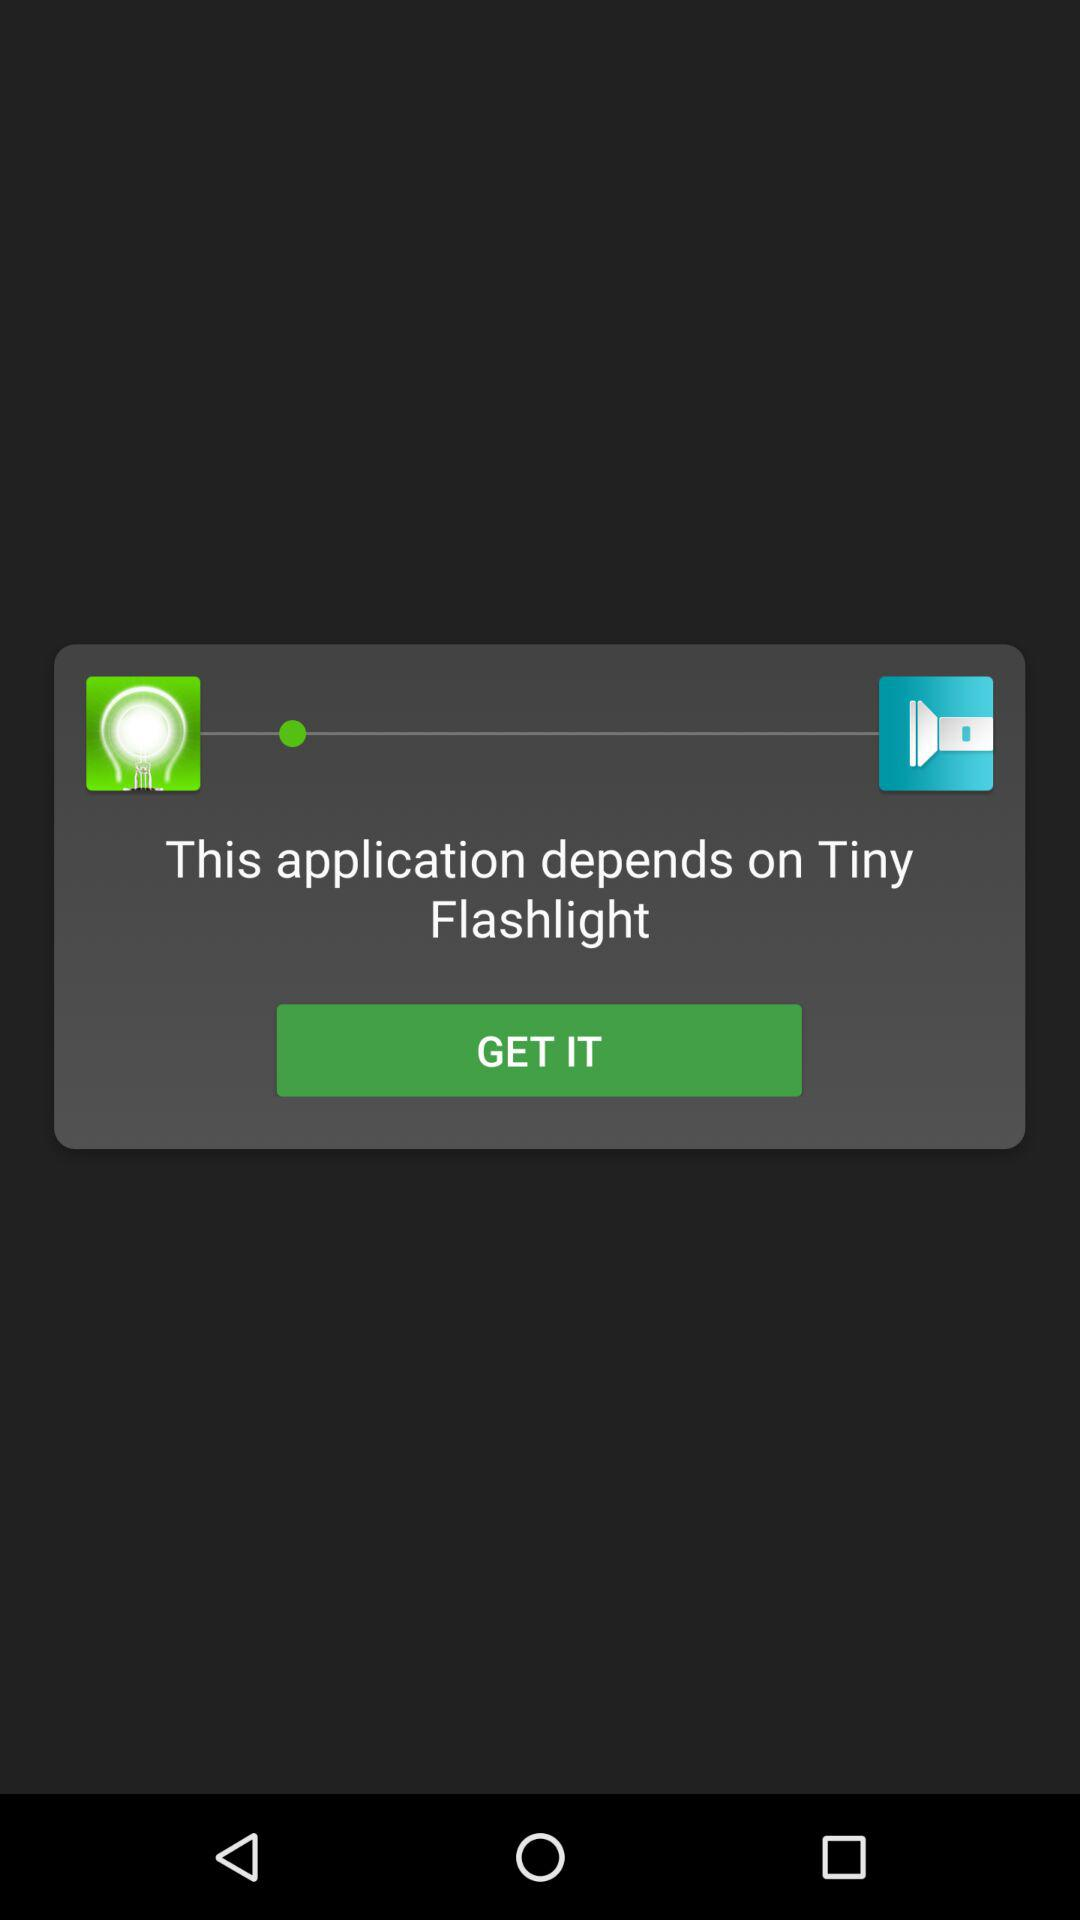What does this application depend on? This application depends on "Tiny Flashlight". 